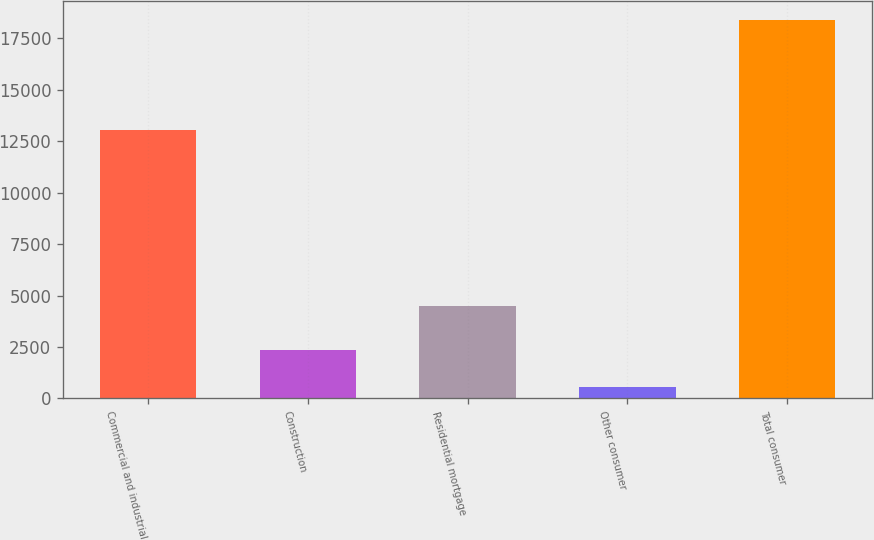<chart> <loc_0><loc_0><loc_500><loc_500><bar_chart><fcel>Commercial and industrial<fcel>Construction<fcel>Residential mortgage<fcel>Other consumer<fcel>Total consumer<nl><fcel>13063<fcel>2348.7<fcel>4500<fcel>566<fcel>18393<nl></chart> 